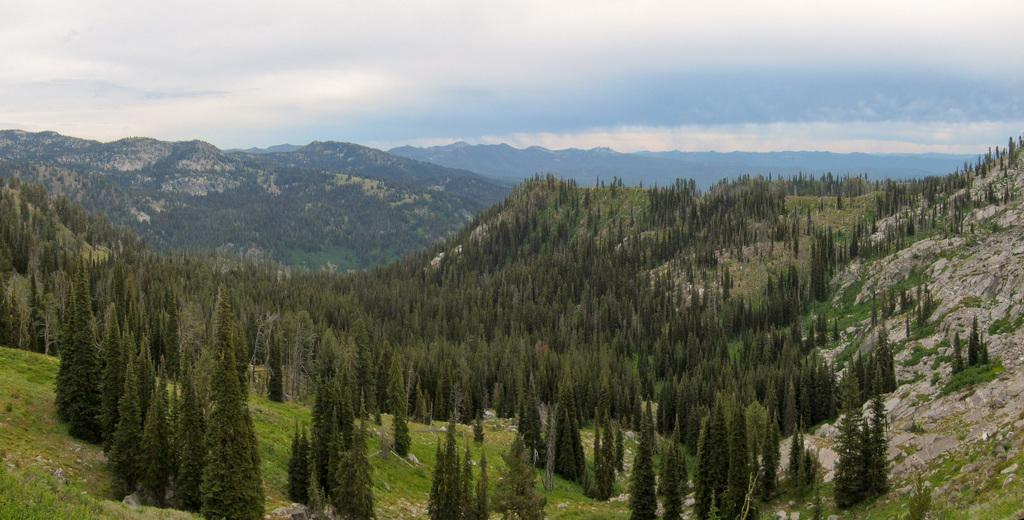What type of natural landscape is depicted in the image? The image contains mountains. What can be found on the mountains in the image? The mountains are full of trees. What is visible above the mountains in the image? There is a sky visible in the image. What can be seen in the sky in the image? Clouds are present in the sky. What type of writing can be seen on the mountains in the image? There is no writing present on the mountains in the image. 